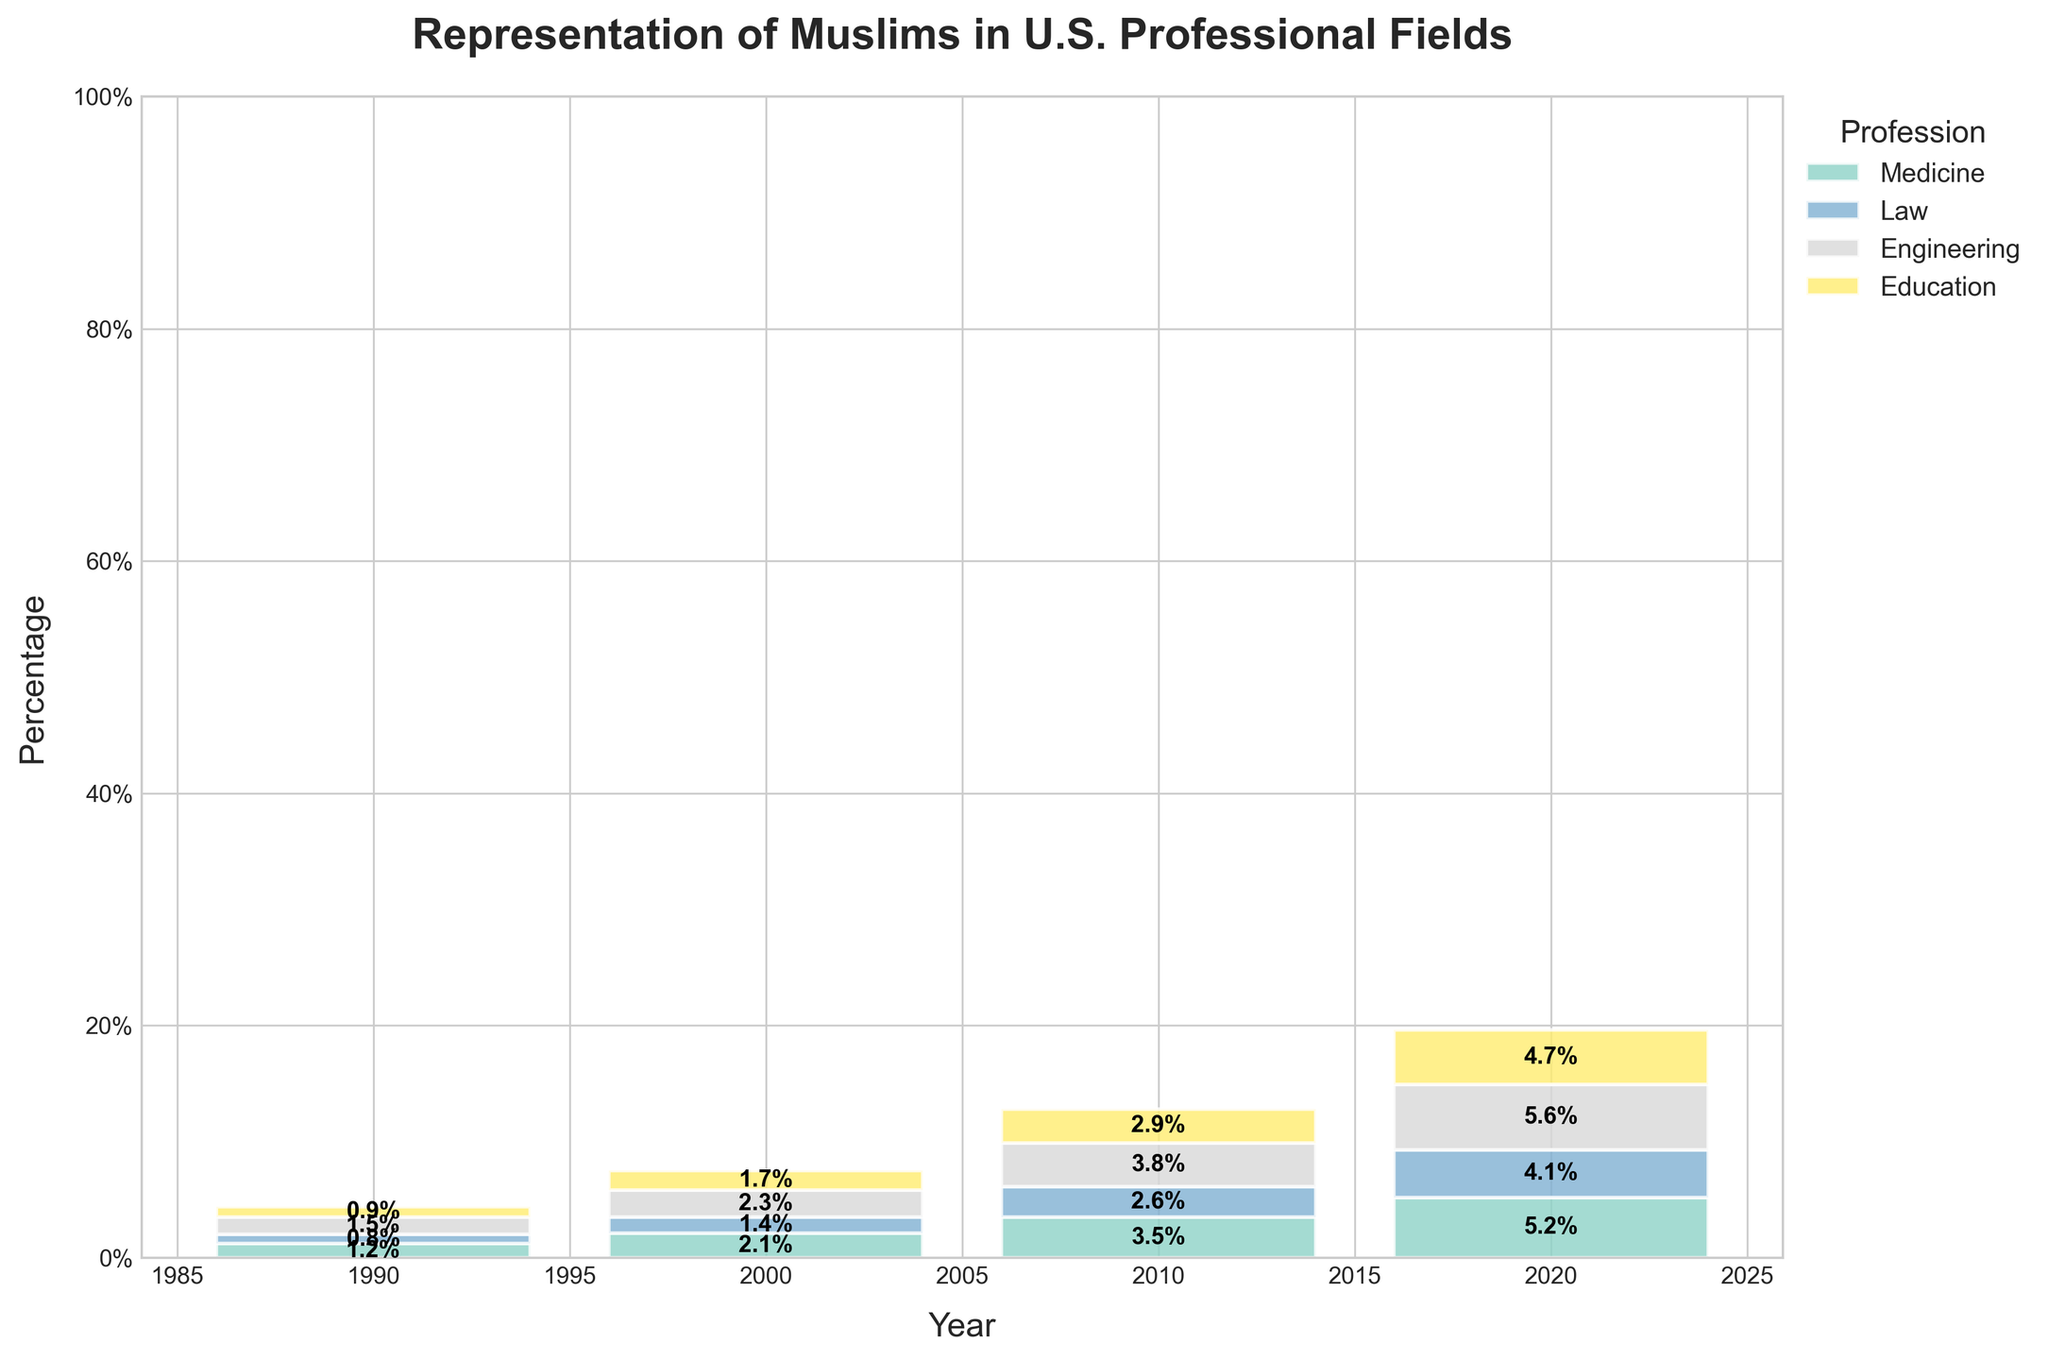what is the title of the figure? The title is usually located at the top of the figure. In this plot, the title indicates the main subject of the data representation.
Answer: Representation of Muslims in U.S. Professional Fields What is the percentage of Muslims in the field of Medicine in 2000? Locate the bar corresponding to the year 2000 and the segment labeled Medicine. Read the percentage value from the figure.
Answer: 2.1% How many professions are represented in the figure? Count the different colors or segments in the bars representing different professions.
Answer: 4 Which profession had the highest percentage increase from 1990 to 2020? Calculate the difference for each profession between 1990 and 2020. Medicine: 5.2 - 1.2 = 4.0; Law: 4.1 - 0.8 = 3.3; Engineering: 5.6 - 1.5 = 4.1; Education: 4.7 - 0.9 = 3.8. Compare the differences.
Answer: Engineering In which year did Muslims have the highest overall representation across all four professions combined? Sum the percentages for all professions for each year and compare the totals.
Answer: 2020 What is the percentage gap between the profession with the highest and the lowest representation in 2010? Identify the highest and lowest percentages for 2010 (Engineering: 3.8%, Law: 2.6%). Compute the difference.
Answer: 1.2% Which profession showed consistent growth in representation in each recorded year? Identify the profession whose percentage increases consecutively from 1990 to 2020.
Answer: All professions What is the total percentage representation of Muslims in all professions in 2000? Sum the percentages for 2000: Medicine: 2.1, Law: 1.4, Engineering: 2.3, Education: 1.7. Total: 2.1 + 1.4 + 2.3 + 1.7
Answer: 7.5% How did the representation of Muslims in the field of Law change from 1990 to 2010? Look at the percentages for Law in 1990 and 2010. Calculate the difference: 2.6% - 0.8%
Answer: Increased by 1.8% Which profession had the closest percentage representation in 2000 and 2010? Compare the percentages for each profession between 2000 and 2010 and find the smallest difference. Medicine: 2.1 vs 3.5 (1.4); Law: 1.4 vs 2.6 (1.2); Engineering: 2.3 vs 3.8 (1.5); Education: 1.7 vs 2.9 (1.2). The smallest difference is in Law and Education.
Answer: Law, Education 